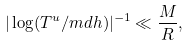Convert formula to latex. <formula><loc_0><loc_0><loc_500><loc_500>| \log ( T ^ { u } / m d h ) | ^ { - 1 } \ll \frac { M } { R } ,</formula> 